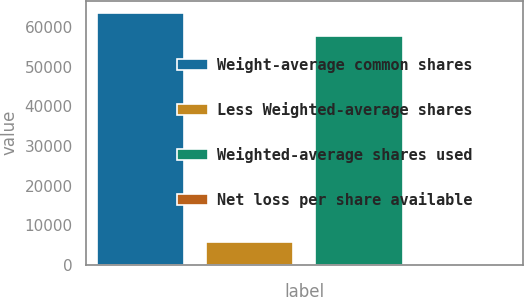Convert chart to OTSL. <chart><loc_0><loc_0><loc_500><loc_500><bar_chart><fcel>Weight-average common shares<fcel>Less Weighted-average shares<fcel>Weighted-average shares used<fcel>Net loss per share available<nl><fcel>63574.6<fcel>5816.92<fcel>57758<fcel>0.35<nl></chart> 